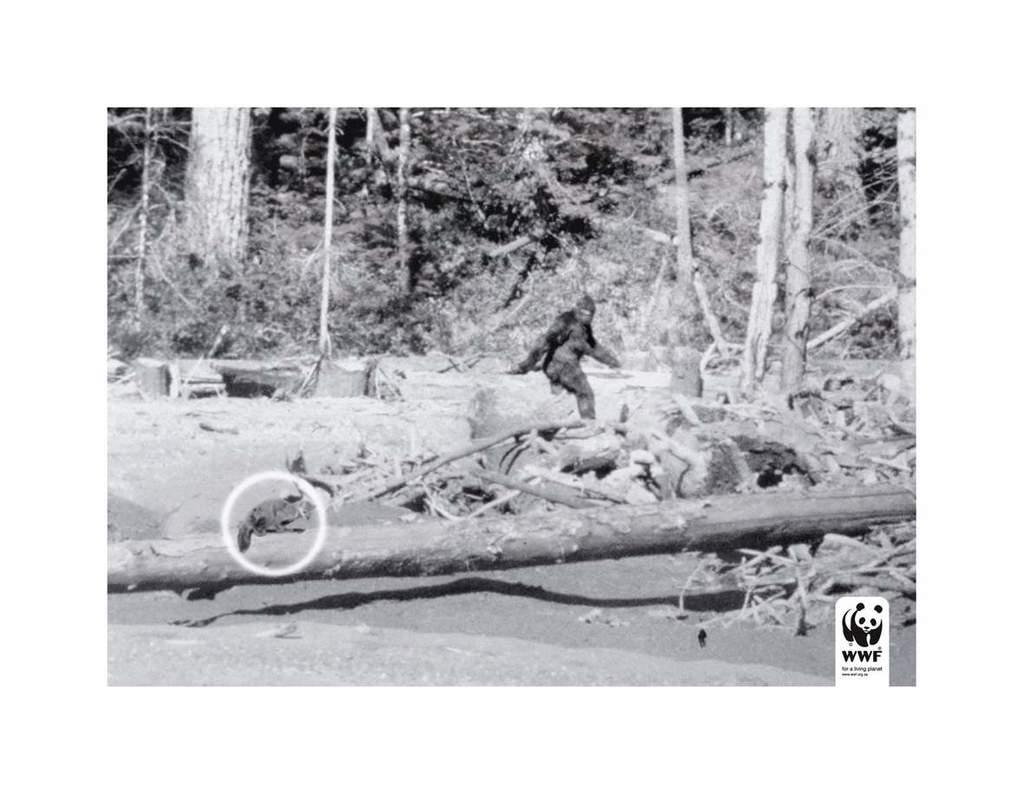What is the main subject of the image? There is an animal on a wooden log in the image. Can you describe the object that resembles an animal? There is an object that resembles an animal in the image. How many wooden logs are visible in the image? There are multiple wooden logs in the image. What can be seen in the background of the image? There are many trees visible in the background of the image. What does the porter do in the image? There is no porter present in the image. What is the animal's belief system in the image? The image does not provide information about the animal's belief system. 